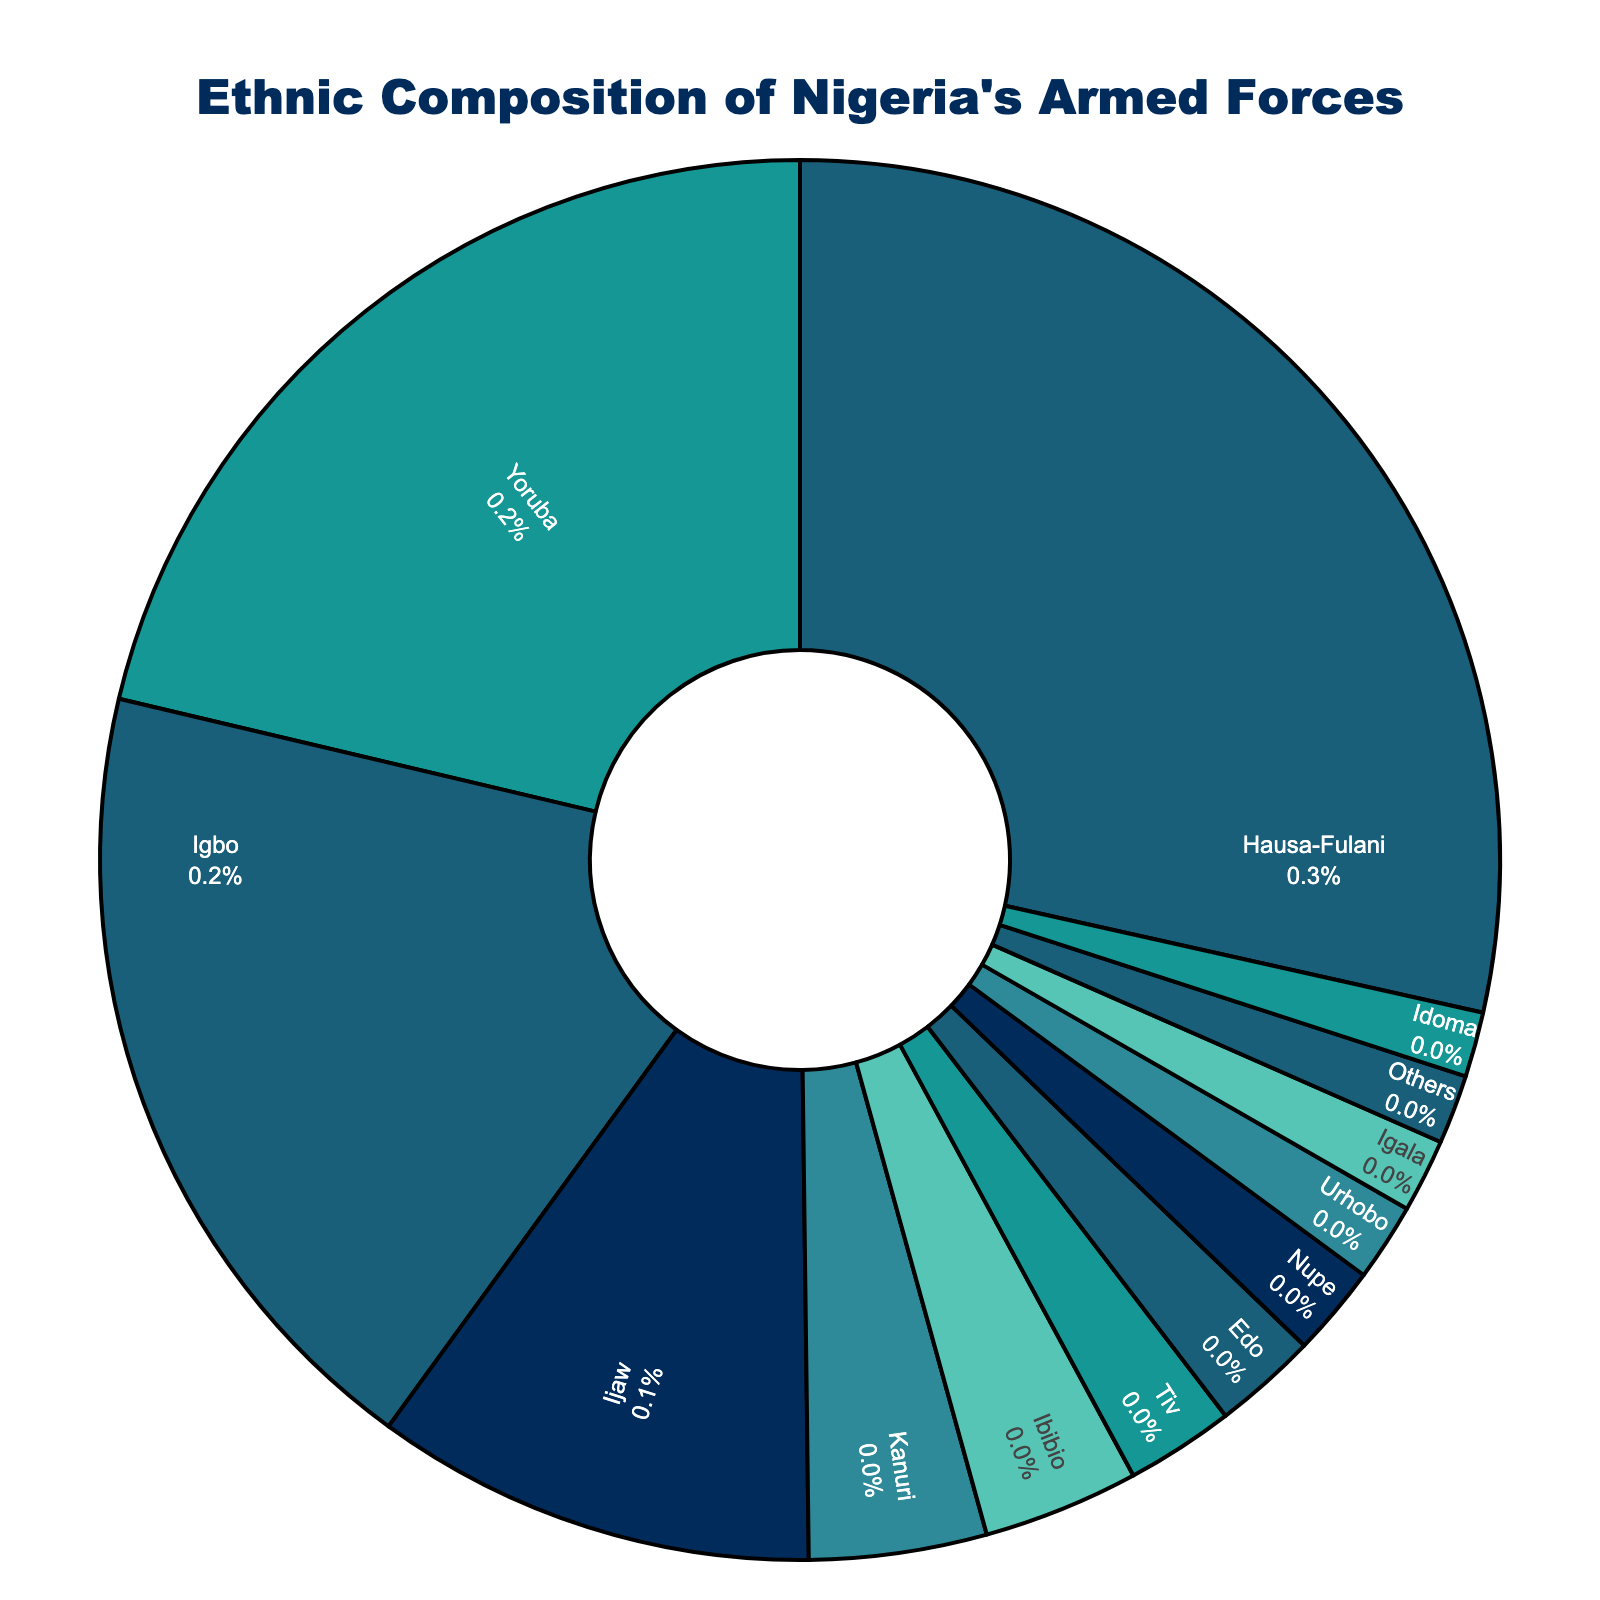What's the percentage of Igbo in Nigeria's armed forces? Identify the Igbo slice in the pie chart and read the percentage value displayed.
Answer: 18.7% How many ethnic groups have a representation of more than 10%? Identify all ethnic groups whose percentage is greater than 10% and count them.
Answer: 3 What is the combined percentage of the Hausa-Fulani and Yoruba groups? Add the percentages of Hausa-Fulani (28.5%) and Yoruba (21.3%). 28.5 + 21.3 = 49.8
Answer: 49.8% Which ethnic group has the smallest representation, and what is its percentage? Find the smallest slice in the pie chart and read its label and percentage.
Answer: Idoma, 1.5% What is the difference in percentage between the Hausa-Fulani and Igbo groups? Subtract the percentage of Igbo (18.7%) from Hausa-Fulani (28.5%). 28.5 - 18.7 = 9.8
Answer: 9.8% Which ethnic groups are represented with a percentage between 1% and 3%? Identify the slices whose percentages fall between 1% and 3%.
Answer: Tiv, Edo, Nupe, Urhobo, Igala, Idoma, Others What is the combined percentage of the Ijaw, Kanuri, and Ibibio groups? Add the percentages of Ijaw (10.2%), Kanuri (4.1%), and Ibibio (3.6%). 10.2 + 4.1 + 3.6 = 17.9
Answer: 17.9% Does the combined percentage of "Others" make up more than any single group? Compare the percentage of "Others" (1.6%) with each individual group.
Answer: No What is the total percentage of the top 3 represented ethnic groups? Identify the top 3 ethnic groups (Hausa-Fulani, Yoruba, Igbo), and add their percentages. 28.5 + 21.3 + 18.7 = 68.5
Answer: 68.5% Which ethnic groups have a percentage almost equal to 2.5%? Compare the percentages and find the ones close to 2.5%.
Answer: Tiv (2.5%), Edo (2.4%) 